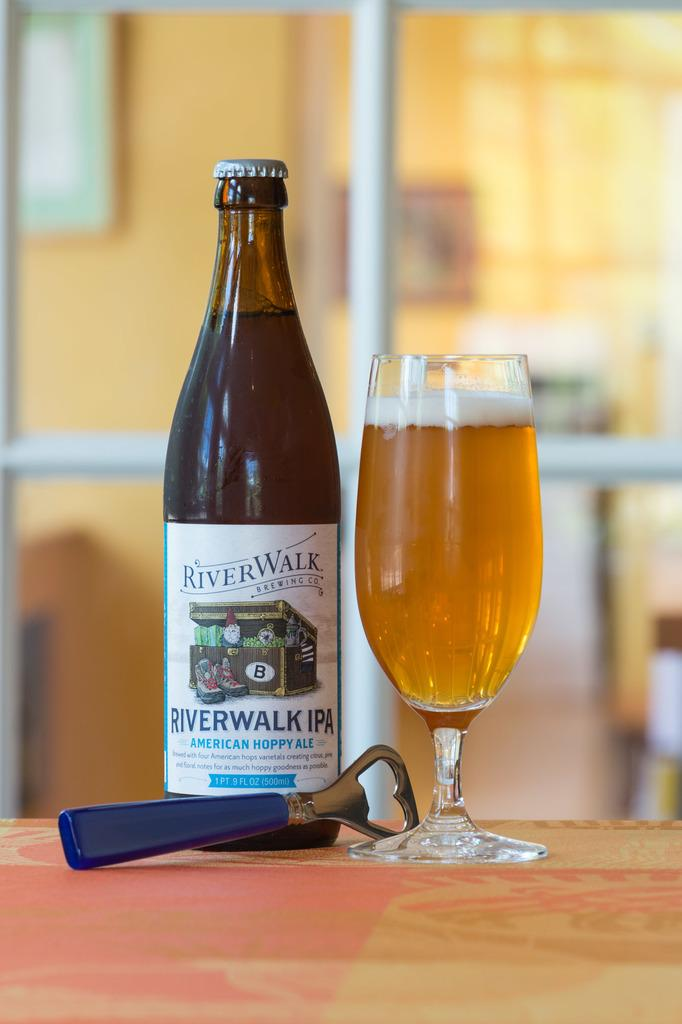<image>
Summarize the visual content of the image. A bottle of River Walk IPA stands beside a full glass with a bottle opener. 